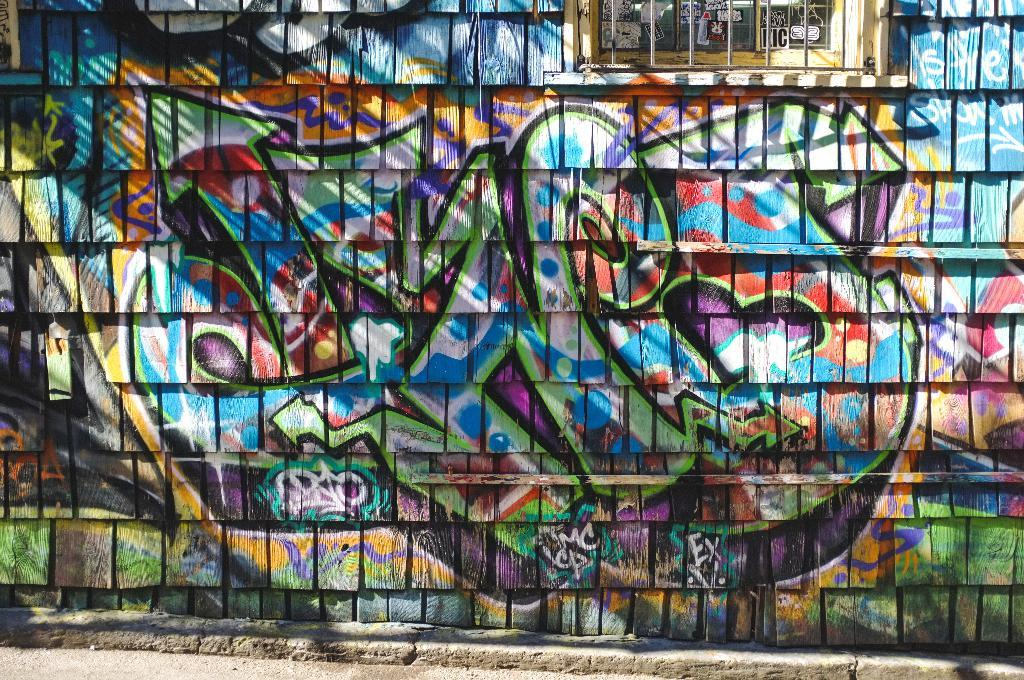What type of structure can be seen in the image? There is a wall in the image. Can you describe any other architectural features in the image? Yes, there is a window in the image. What is present on the wall in the image? There is graffiti on the wall in the image. What is the sum of the numbers 7 and 43 in the image? There are no numbers or any indication of addition in the image. What type of fruit is depicted in the graffiti on the wall? There is no fruit, specifically quince, depicted in the graffiti on the wall; it is not present in the image. 